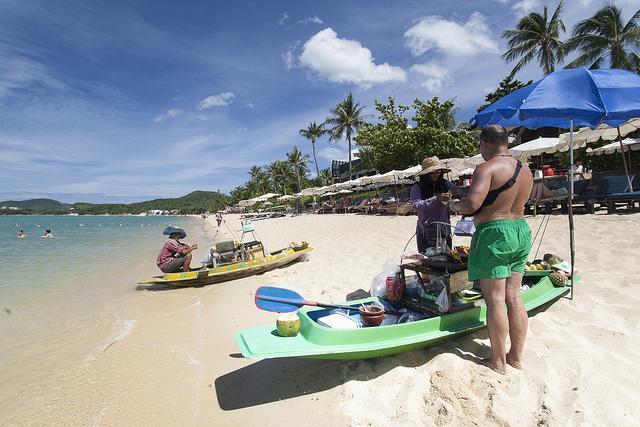How many boats are there?
Give a very brief answer. 2. How many people can you see?
Give a very brief answer. 2. How many bears have bows?
Give a very brief answer. 0. 